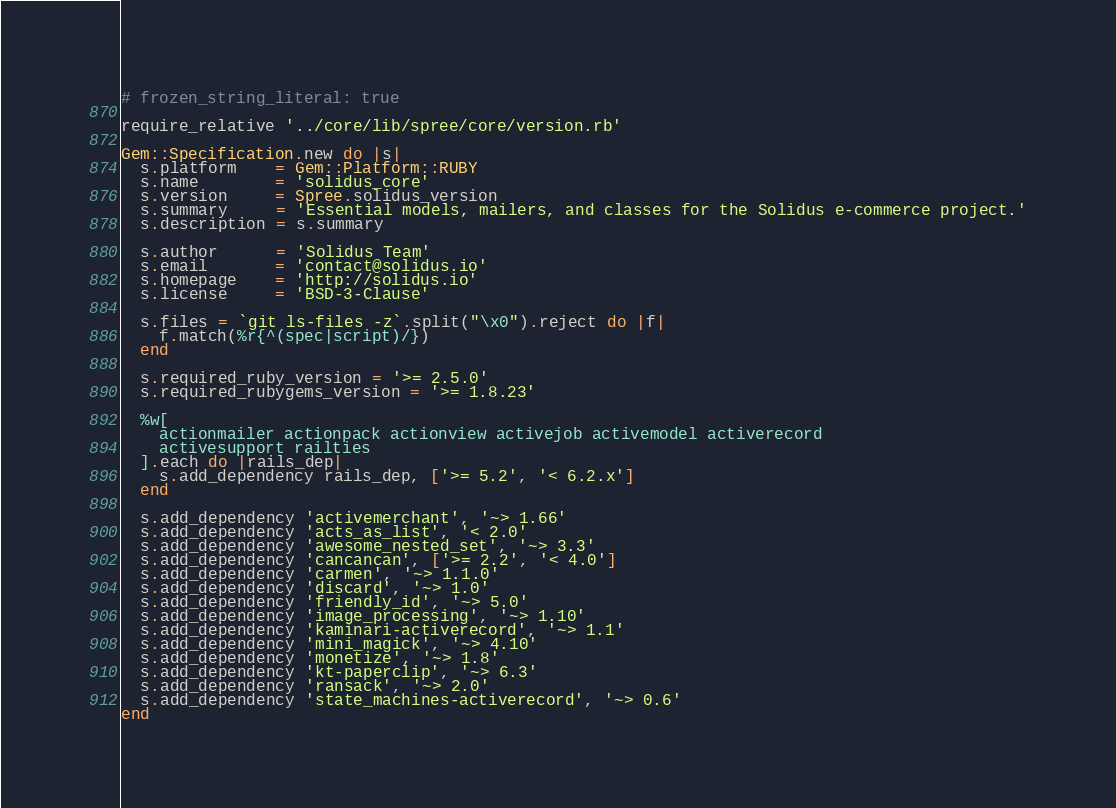Convert code to text. <code><loc_0><loc_0><loc_500><loc_500><_Ruby_># frozen_string_literal: true

require_relative '../core/lib/spree/core/version.rb'

Gem::Specification.new do |s|
  s.platform    = Gem::Platform::RUBY
  s.name        = 'solidus_core'
  s.version     = Spree.solidus_version
  s.summary     = 'Essential models, mailers, and classes for the Solidus e-commerce project.'
  s.description = s.summary

  s.author      = 'Solidus Team'
  s.email       = 'contact@solidus.io'
  s.homepage    = 'http://solidus.io'
  s.license     = 'BSD-3-Clause'

  s.files = `git ls-files -z`.split("\x0").reject do |f|
    f.match(%r{^(spec|script)/})
  end

  s.required_ruby_version = '>= 2.5.0'
  s.required_rubygems_version = '>= 1.8.23'

  %w[
    actionmailer actionpack actionview activejob activemodel activerecord
    activesupport railties
  ].each do |rails_dep|
    s.add_dependency rails_dep, ['>= 5.2', '< 6.2.x']
  end

  s.add_dependency 'activemerchant', '~> 1.66'
  s.add_dependency 'acts_as_list', '< 2.0'
  s.add_dependency 'awesome_nested_set', '~> 3.3'
  s.add_dependency 'cancancan', ['>= 2.2', '< 4.0']
  s.add_dependency 'carmen', '~> 1.1.0'
  s.add_dependency 'discard', '~> 1.0'
  s.add_dependency 'friendly_id', '~> 5.0'
  s.add_dependency 'image_processing', '~> 1.10'
  s.add_dependency 'kaminari-activerecord', '~> 1.1'
  s.add_dependency 'mini_magick', '~> 4.10'
  s.add_dependency 'monetize', '~> 1.8'
  s.add_dependency 'kt-paperclip', '~> 6.3'
  s.add_dependency 'ransack', '~> 2.0'
  s.add_dependency 'state_machines-activerecord', '~> 0.6'
end
</code> 